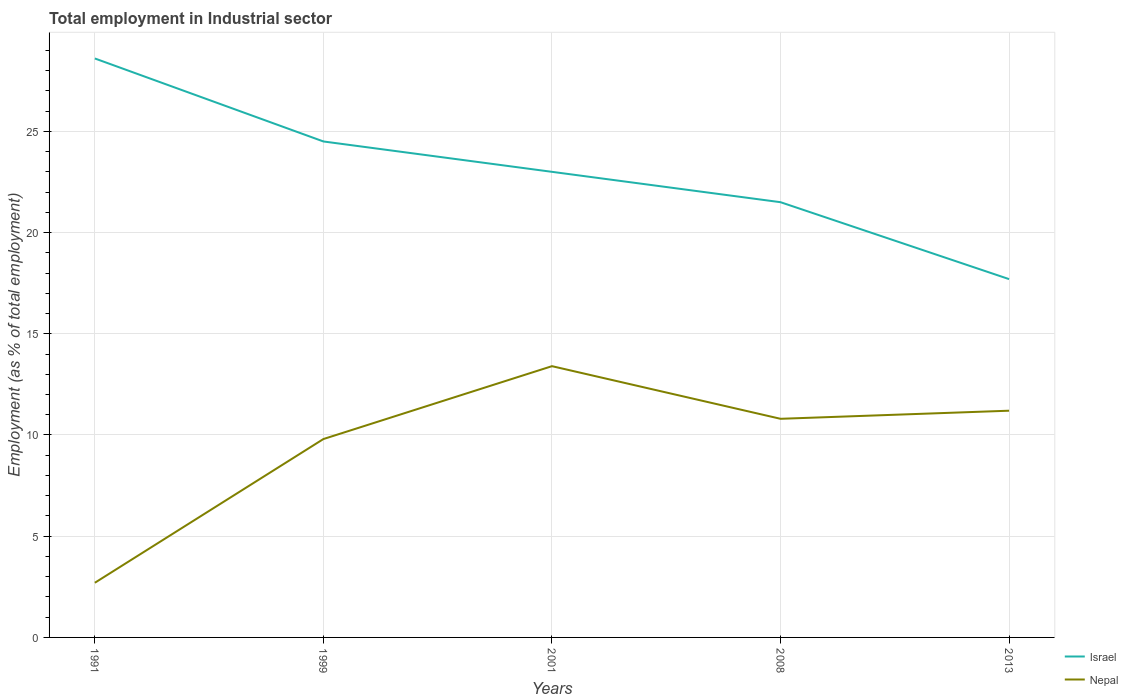Is the number of lines equal to the number of legend labels?
Your answer should be very brief. Yes. Across all years, what is the maximum employment in industrial sector in Nepal?
Offer a very short reply. 2.7. In which year was the employment in industrial sector in Israel maximum?
Provide a short and direct response. 2013. What is the total employment in industrial sector in Nepal in the graph?
Your answer should be compact. -1. What is the difference between the highest and the second highest employment in industrial sector in Nepal?
Ensure brevity in your answer.  10.7. What is the difference between the highest and the lowest employment in industrial sector in Nepal?
Provide a succinct answer. 4. Is the employment in industrial sector in Nepal strictly greater than the employment in industrial sector in Israel over the years?
Provide a short and direct response. Yes. How many lines are there?
Ensure brevity in your answer.  2. How many years are there in the graph?
Make the answer very short. 5. What is the difference between two consecutive major ticks on the Y-axis?
Ensure brevity in your answer.  5. Does the graph contain any zero values?
Ensure brevity in your answer.  No. Where does the legend appear in the graph?
Your answer should be compact. Bottom right. How are the legend labels stacked?
Make the answer very short. Vertical. What is the title of the graph?
Your answer should be compact. Total employment in Industrial sector. Does "Slovenia" appear as one of the legend labels in the graph?
Make the answer very short. No. What is the label or title of the Y-axis?
Provide a succinct answer. Employment (as % of total employment). What is the Employment (as % of total employment) of Israel in 1991?
Offer a very short reply. 28.6. What is the Employment (as % of total employment) of Nepal in 1991?
Provide a succinct answer. 2.7. What is the Employment (as % of total employment) in Nepal in 1999?
Your answer should be compact. 9.8. What is the Employment (as % of total employment) of Israel in 2001?
Ensure brevity in your answer.  23. What is the Employment (as % of total employment) of Nepal in 2001?
Your answer should be very brief. 13.4. What is the Employment (as % of total employment) in Nepal in 2008?
Keep it short and to the point. 10.8. What is the Employment (as % of total employment) of Israel in 2013?
Your answer should be compact. 17.7. What is the Employment (as % of total employment) of Nepal in 2013?
Offer a terse response. 11.2. Across all years, what is the maximum Employment (as % of total employment) of Israel?
Make the answer very short. 28.6. Across all years, what is the maximum Employment (as % of total employment) of Nepal?
Offer a terse response. 13.4. Across all years, what is the minimum Employment (as % of total employment) of Israel?
Your answer should be very brief. 17.7. Across all years, what is the minimum Employment (as % of total employment) in Nepal?
Your answer should be very brief. 2.7. What is the total Employment (as % of total employment) of Israel in the graph?
Provide a succinct answer. 115.3. What is the total Employment (as % of total employment) of Nepal in the graph?
Offer a very short reply. 47.9. What is the difference between the Employment (as % of total employment) of Israel in 1991 and that in 1999?
Provide a succinct answer. 4.1. What is the difference between the Employment (as % of total employment) of Israel in 1991 and that in 2001?
Your answer should be compact. 5.6. What is the difference between the Employment (as % of total employment) in Israel in 1991 and that in 2008?
Provide a short and direct response. 7.1. What is the difference between the Employment (as % of total employment) of Israel in 1991 and that in 2013?
Your answer should be very brief. 10.9. What is the difference between the Employment (as % of total employment) in Nepal in 1991 and that in 2013?
Ensure brevity in your answer.  -8.5. What is the difference between the Employment (as % of total employment) in Nepal in 1999 and that in 2001?
Your answer should be very brief. -3.6. What is the difference between the Employment (as % of total employment) of Israel in 1999 and that in 2013?
Keep it short and to the point. 6.8. What is the difference between the Employment (as % of total employment) of Israel in 2001 and that in 2013?
Your response must be concise. 5.3. What is the difference between the Employment (as % of total employment) in Nepal in 2001 and that in 2013?
Your answer should be compact. 2.2. What is the difference between the Employment (as % of total employment) in Israel in 2001 and the Employment (as % of total employment) in Nepal in 2013?
Keep it short and to the point. 11.8. What is the average Employment (as % of total employment) in Israel per year?
Offer a terse response. 23.06. What is the average Employment (as % of total employment) in Nepal per year?
Your answer should be very brief. 9.58. In the year 1991, what is the difference between the Employment (as % of total employment) in Israel and Employment (as % of total employment) in Nepal?
Provide a succinct answer. 25.9. In the year 1999, what is the difference between the Employment (as % of total employment) of Israel and Employment (as % of total employment) of Nepal?
Offer a terse response. 14.7. In the year 2001, what is the difference between the Employment (as % of total employment) in Israel and Employment (as % of total employment) in Nepal?
Give a very brief answer. 9.6. In the year 2008, what is the difference between the Employment (as % of total employment) in Israel and Employment (as % of total employment) in Nepal?
Ensure brevity in your answer.  10.7. What is the ratio of the Employment (as % of total employment) in Israel in 1991 to that in 1999?
Provide a short and direct response. 1.17. What is the ratio of the Employment (as % of total employment) of Nepal in 1991 to that in 1999?
Give a very brief answer. 0.28. What is the ratio of the Employment (as % of total employment) in Israel in 1991 to that in 2001?
Keep it short and to the point. 1.24. What is the ratio of the Employment (as % of total employment) in Nepal in 1991 to that in 2001?
Your response must be concise. 0.2. What is the ratio of the Employment (as % of total employment) in Israel in 1991 to that in 2008?
Your answer should be compact. 1.33. What is the ratio of the Employment (as % of total employment) of Nepal in 1991 to that in 2008?
Give a very brief answer. 0.25. What is the ratio of the Employment (as % of total employment) of Israel in 1991 to that in 2013?
Make the answer very short. 1.62. What is the ratio of the Employment (as % of total employment) in Nepal in 1991 to that in 2013?
Make the answer very short. 0.24. What is the ratio of the Employment (as % of total employment) of Israel in 1999 to that in 2001?
Your answer should be very brief. 1.07. What is the ratio of the Employment (as % of total employment) in Nepal in 1999 to that in 2001?
Keep it short and to the point. 0.73. What is the ratio of the Employment (as % of total employment) of Israel in 1999 to that in 2008?
Offer a very short reply. 1.14. What is the ratio of the Employment (as % of total employment) in Nepal in 1999 to that in 2008?
Your answer should be compact. 0.91. What is the ratio of the Employment (as % of total employment) of Israel in 1999 to that in 2013?
Your answer should be very brief. 1.38. What is the ratio of the Employment (as % of total employment) in Nepal in 1999 to that in 2013?
Offer a very short reply. 0.88. What is the ratio of the Employment (as % of total employment) in Israel in 2001 to that in 2008?
Your answer should be compact. 1.07. What is the ratio of the Employment (as % of total employment) in Nepal in 2001 to that in 2008?
Your answer should be compact. 1.24. What is the ratio of the Employment (as % of total employment) of Israel in 2001 to that in 2013?
Offer a very short reply. 1.3. What is the ratio of the Employment (as % of total employment) of Nepal in 2001 to that in 2013?
Offer a very short reply. 1.2. What is the ratio of the Employment (as % of total employment) in Israel in 2008 to that in 2013?
Your answer should be very brief. 1.21. What is the ratio of the Employment (as % of total employment) of Nepal in 2008 to that in 2013?
Keep it short and to the point. 0.96. What is the difference between the highest and the second highest Employment (as % of total employment) of Nepal?
Make the answer very short. 2.2. What is the difference between the highest and the lowest Employment (as % of total employment) of Israel?
Your response must be concise. 10.9. 